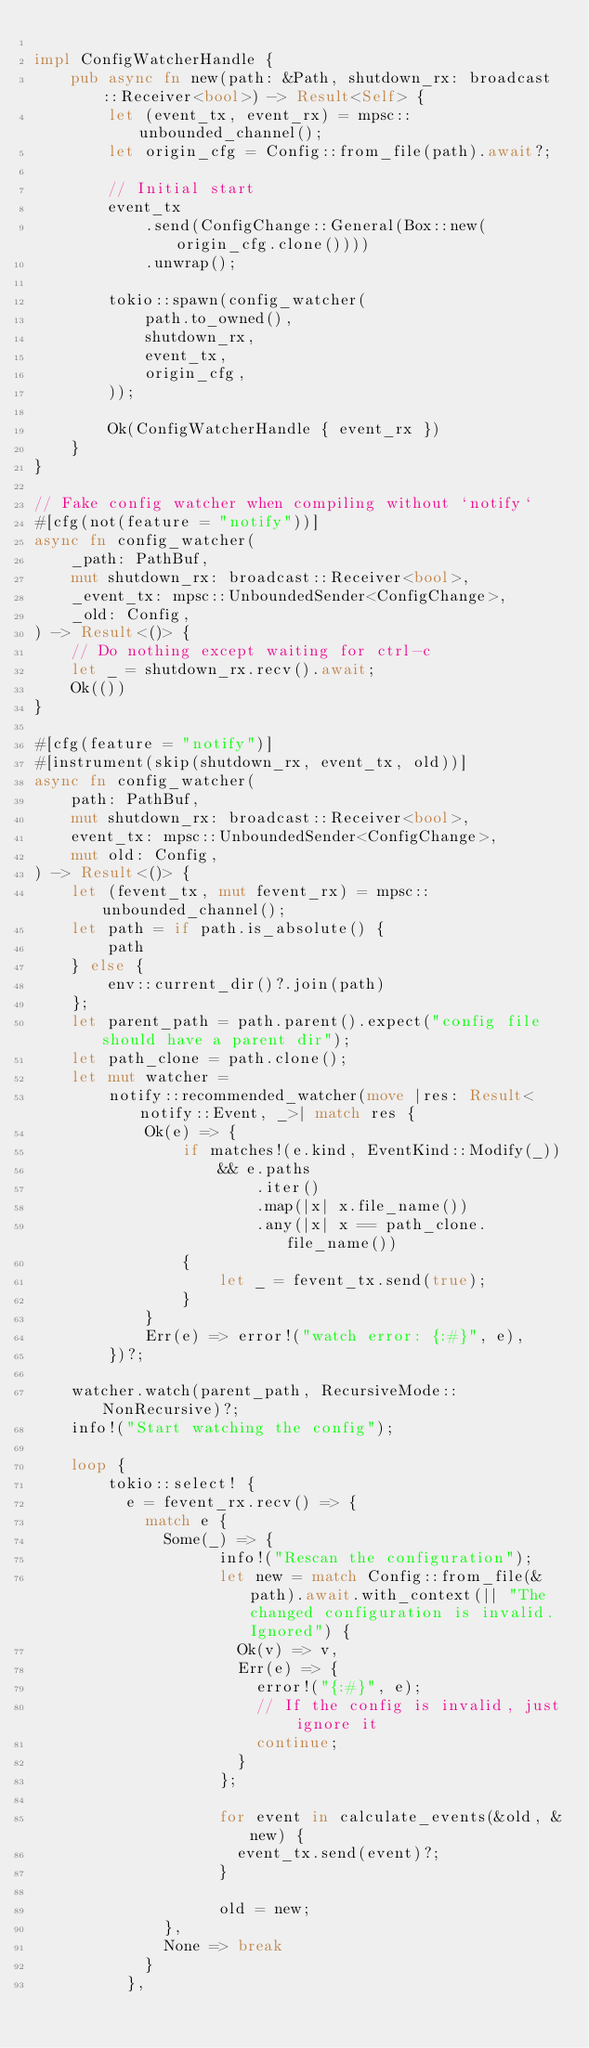Convert code to text. <code><loc_0><loc_0><loc_500><loc_500><_Rust_>
impl ConfigWatcherHandle {
    pub async fn new(path: &Path, shutdown_rx: broadcast::Receiver<bool>) -> Result<Self> {
        let (event_tx, event_rx) = mpsc::unbounded_channel();
        let origin_cfg = Config::from_file(path).await?;

        // Initial start
        event_tx
            .send(ConfigChange::General(Box::new(origin_cfg.clone())))
            .unwrap();

        tokio::spawn(config_watcher(
            path.to_owned(),
            shutdown_rx,
            event_tx,
            origin_cfg,
        ));

        Ok(ConfigWatcherHandle { event_rx })
    }
}

// Fake config watcher when compiling without `notify`
#[cfg(not(feature = "notify"))]
async fn config_watcher(
    _path: PathBuf,
    mut shutdown_rx: broadcast::Receiver<bool>,
    _event_tx: mpsc::UnboundedSender<ConfigChange>,
    _old: Config,
) -> Result<()> {
    // Do nothing except waiting for ctrl-c
    let _ = shutdown_rx.recv().await;
    Ok(())
}

#[cfg(feature = "notify")]
#[instrument(skip(shutdown_rx, event_tx, old))]
async fn config_watcher(
    path: PathBuf,
    mut shutdown_rx: broadcast::Receiver<bool>,
    event_tx: mpsc::UnboundedSender<ConfigChange>,
    mut old: Config,
) -> Result<()> {
    let (fevent_tx, mut fevent_rx) = mpsc::unbounded_channel();
    let path = if path.is_absolute() {
        path
    } else {
        env::current_dir()?.join(path)
    };
    let parent_path = path.parent().expect("config file should have a parent dir");
    let path_clone = path.clone();
    let mut watcher =
        notify::recommended_watcher(move |res: Result<notify::Event, _>| match res {
            Ok(e) => {
                if matches!(e.kind, EventKind::Modify(_))
                    && e.paths
                        .iter()
                        .map(|x| x.file_name())
                        .any(|x| x == path_clone.file_name())
                {
                    let _ = fevent_tx.send(true);
                }
            }
            Err(e) => error!("watch error: {:#}", e),
        })?;

    watcher.watch(parent_path, RecursiveMode::NonRecursive)?;
    info!("Start watching the config");

    loop {
        tokio::select! {
          e = fevent_rx.recv() => {
            match e {
              Some(_) => {
                    info!("Rescan the configuration");
                    let new = match Config::from_file(&path).await.with_context(|| "The changed configuration is invalid. Ignored") {
                      Ok(v) => v,
                      Err(e) => {
                        error!("{:#}", e);
                        // If the config is invalid, just ignore it
                        continue;
                      }
                    };

                    for event in calculate_events(&old, &new) {
                      event_tx.send(event)?;
                    }

                    old = new;
              },
              None => break
            }
          },</code> 